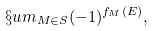<formula> <loc_0><loc_0><loc_500><loc_500>\S u m _ { M \in S } ( - 1 ) ^ { f _ { M } ( E ) } ,</formula> 